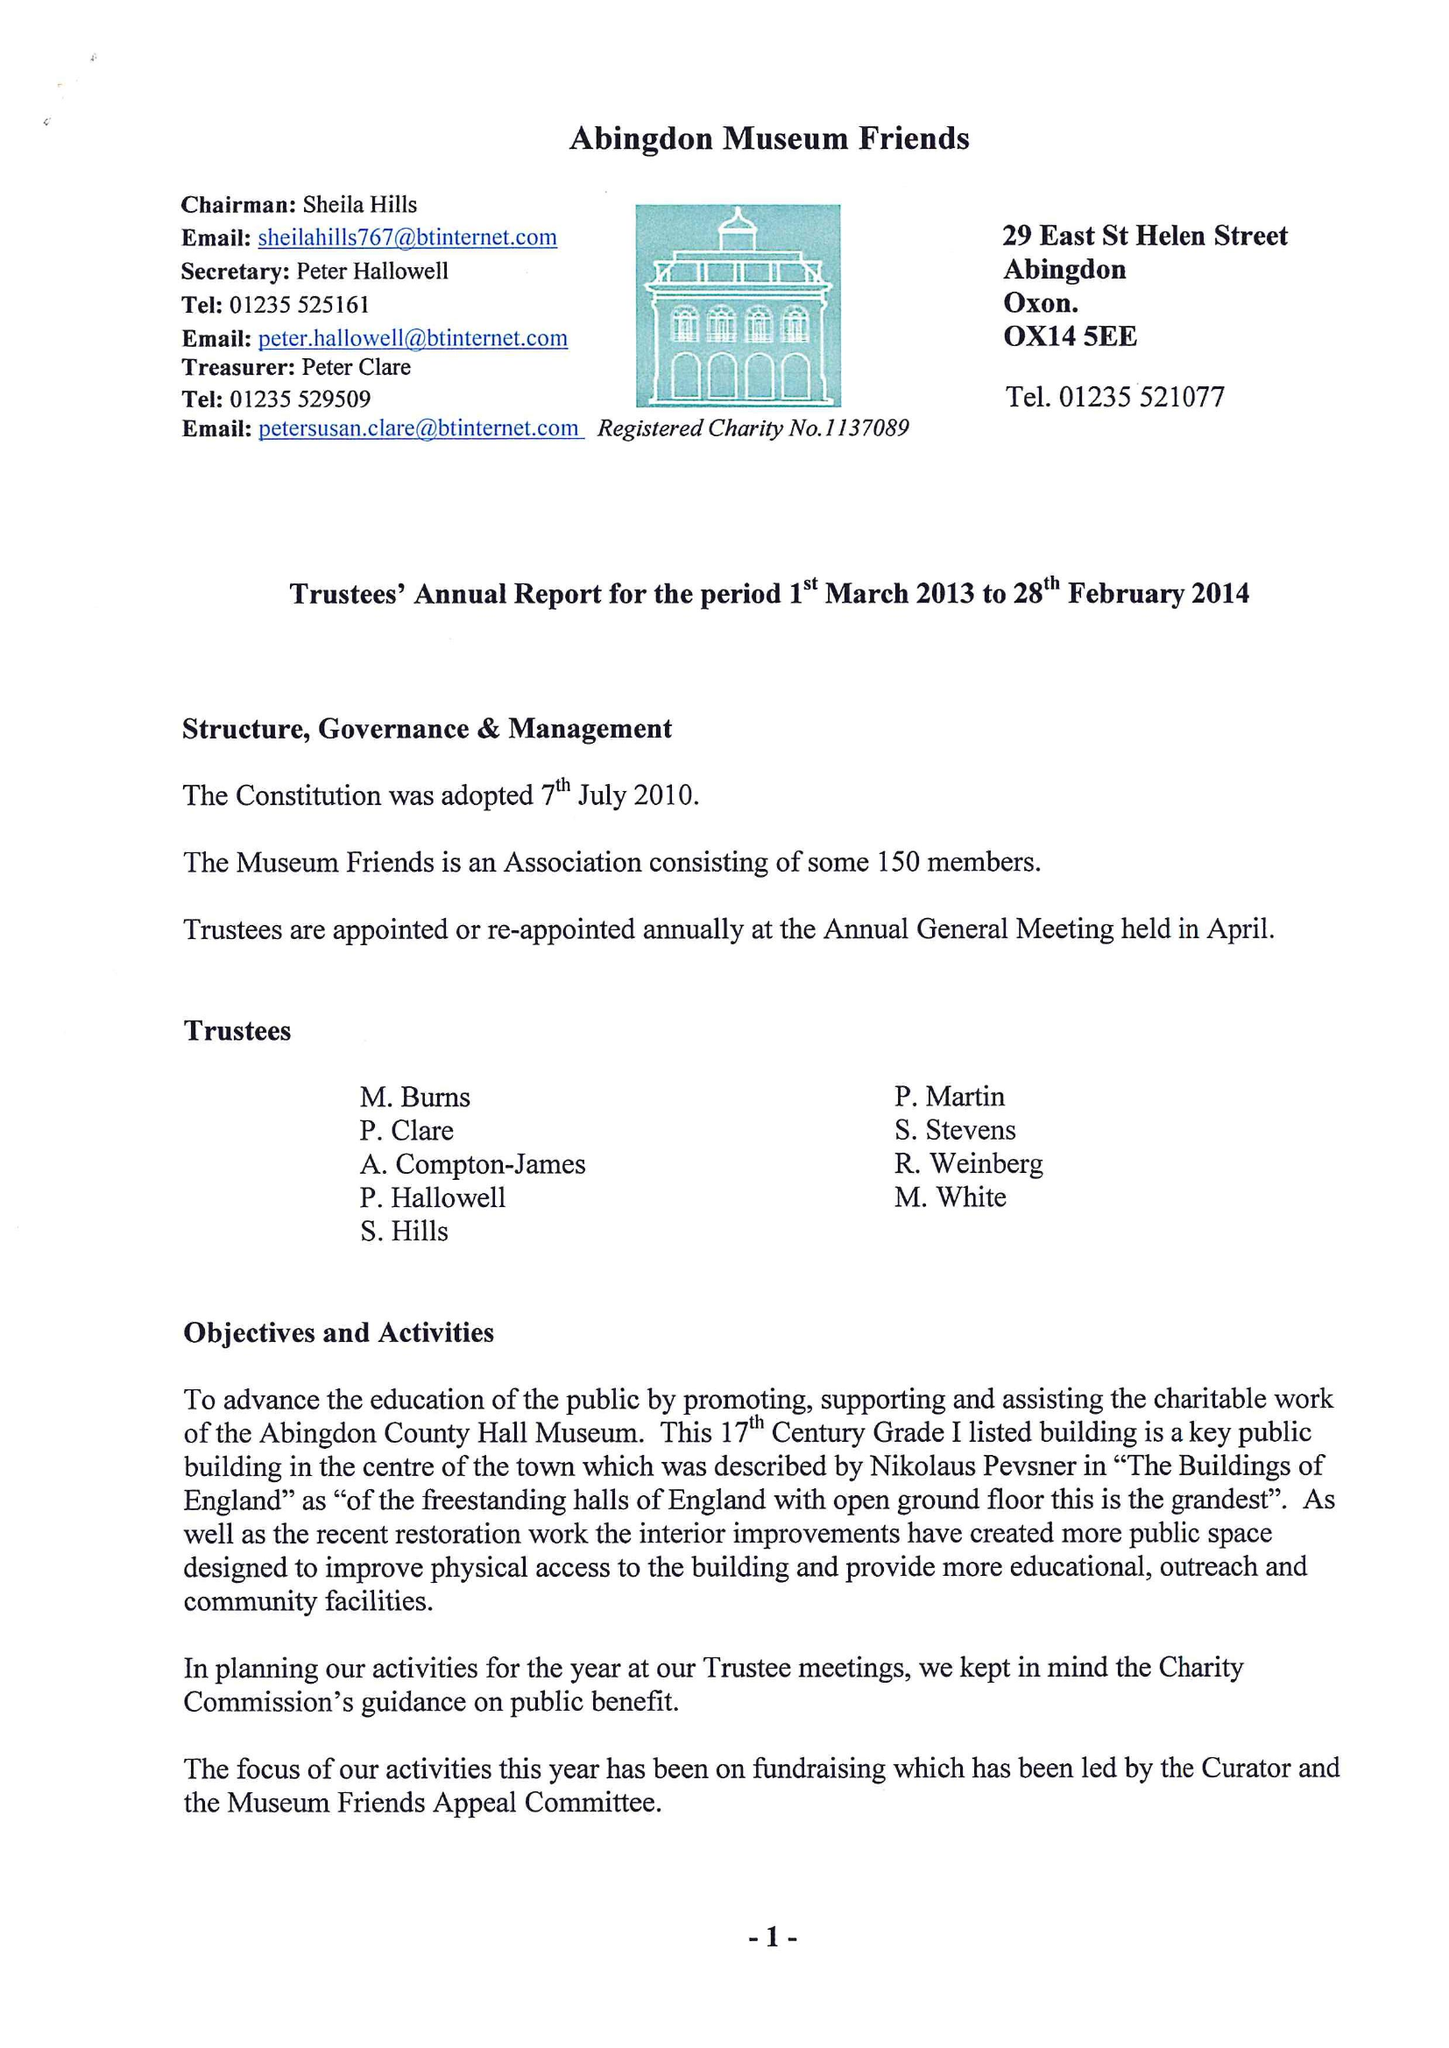What is the value for the spending_annually_in_british_pounds?
Answer the question using a single word or phrase. 36464.00 